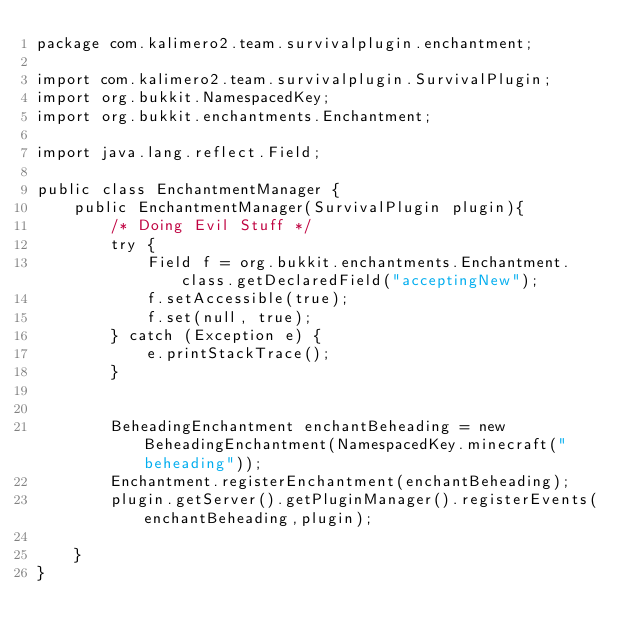Convert code to text. <code><loc_0><loc_0><loc_500><loc_500><_Java_>package com.kalimero2.team.survivalplugin.enchantment;

import com.kalimero2.team.survivalplugin.SurvivalPlugin;
import org.bukkit.NamespacedKey;
import org.bukkit.enchantments.Enchantment;

import java.lang.reflect.Field;

public class EnchantmentManager {
    public EnchantmentManager(SurvivalPlugin plugin){
        /* Doing Evil Stuff */
        try {
            Field f = org.bukkit.enchantments.Enchantment.class.getDeclaredField("acceptingNew");
            f.setAccessible(true);
            f.set(null, true);
        } catch (Exception e) {
            e.printStackTrace();
        }


        BeheadingEnchantment enchantBeheading = new BeheadingEnchantment(NamespacedKey.minecraft("beheading"));
        Enchantment.registerEnchantment(enchantBeheading);
        plugin.getServer().getPluginManager().registerEvents(enchantBeheading,plugin);

    }
}
</code> 